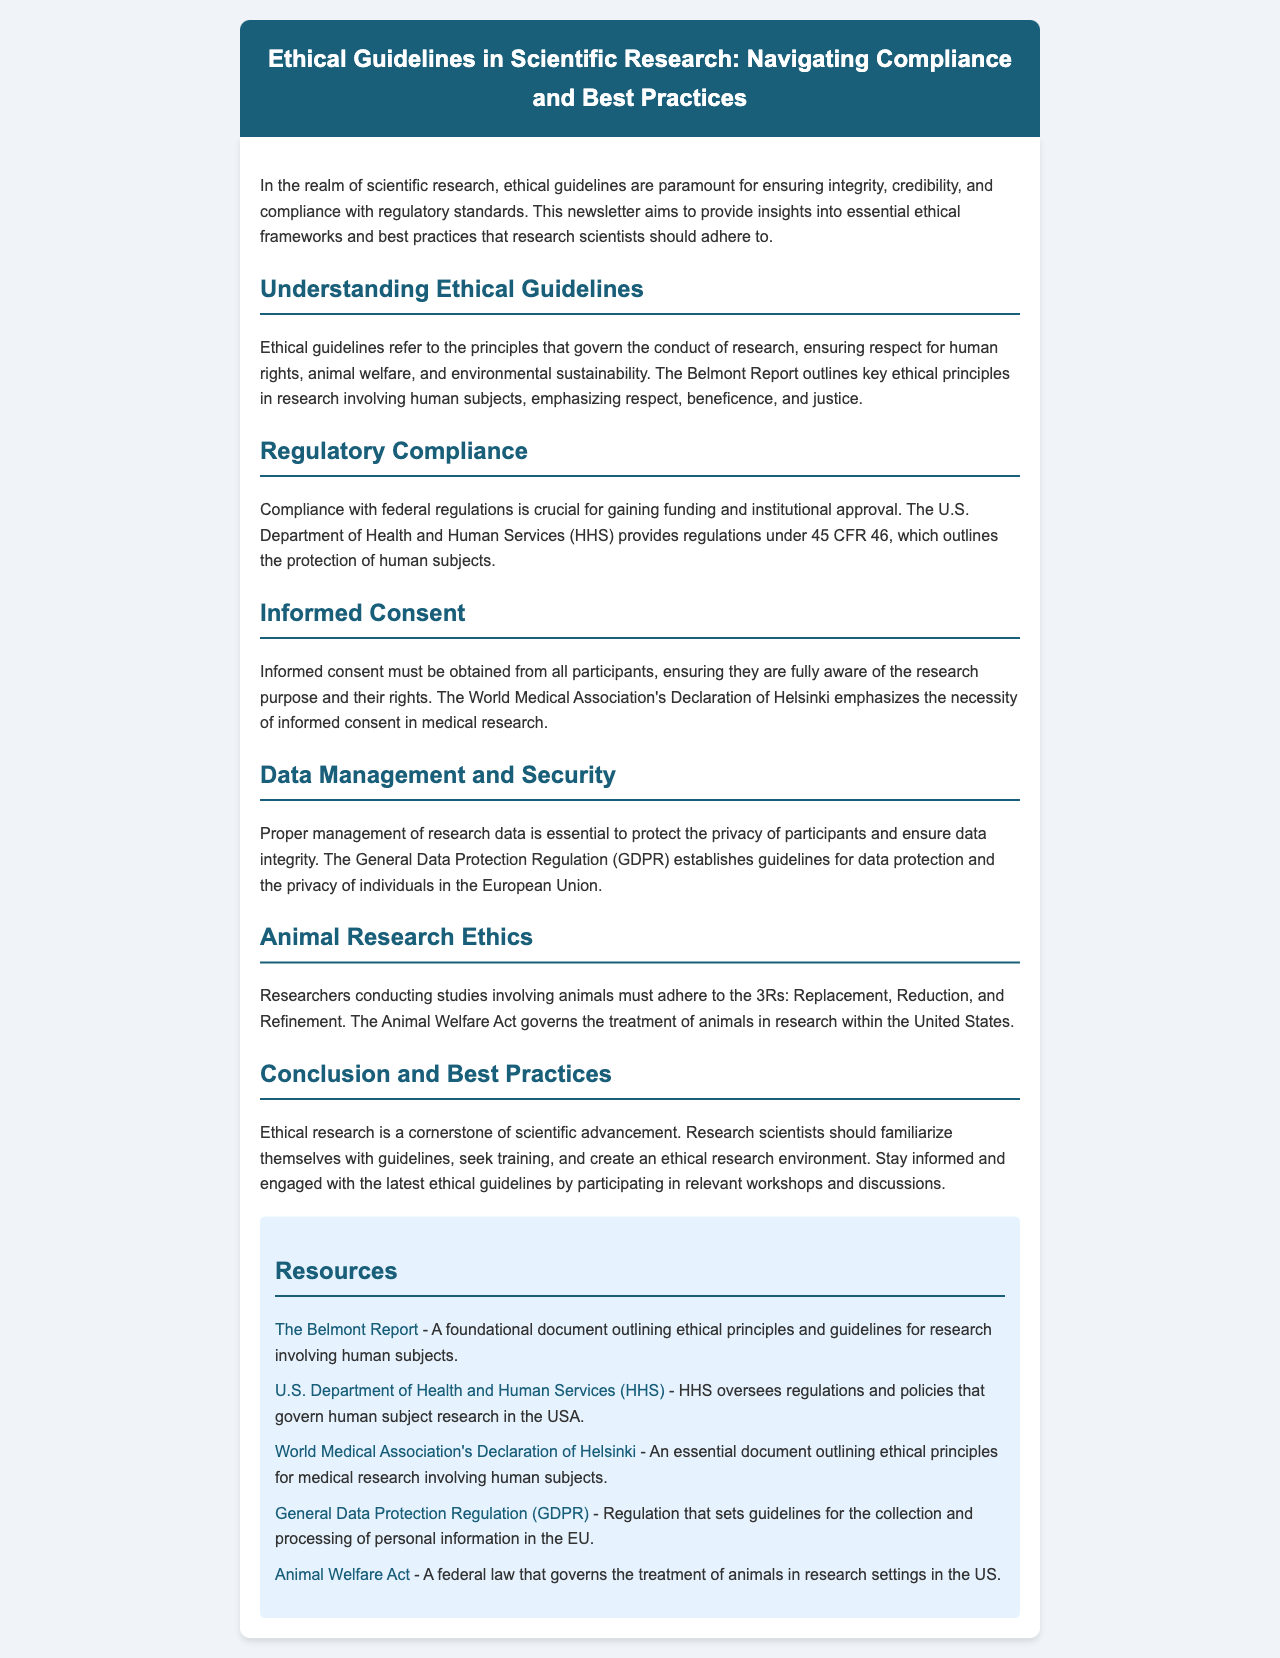what is the title of the newsletter? The title is printed at the top of the document, highlighting the main topic of discussion.
Answer: Ethical Guidelines in Scientific Research: Navigating Compliance and Best Practices what does the Belmont Report emphasize? The Belmont Report outlines key ethical principles in research involving human subjects.
Answer: respect, beneficence, and justice which department provides regulations under 45 CFR 46? The document specifies which government body issues regulations relevant to human subjects research.
Answer: U.S. Department of Health and Human Services what is the primary focus of the Declaration of Helsinki? The Declaration emphasizes particular ethical considerations critical to medical research involving participants.
Answer: necessity of informed consent what are the 3Rs in animal research ethics? The document references guidelines that structure ethical animal research practices.
Answer: Replacement, Reduction, and Refinement why is ethical research considered essential? The conclusion discusses the role of ethical adherence in the progression of scientific endeavors.
Answer: cornerstone of scientific advancement which regulation sets guidelines for data protection in the EU? The document mentions a specific regulation that governs personal data in Europe.
Answer: General Data Protection Regulation (GDPR) what should research scientists do to stay informed about ethical guidelines? The conclusion suggests actions to ensure ongoing awareness of ethical issues in research practices.
Answer: participate in relevant workshops and discussions what color is the header of the newsletter? The design details describe the aesthetics of the document, specifically the header.
Answer: dark blue 